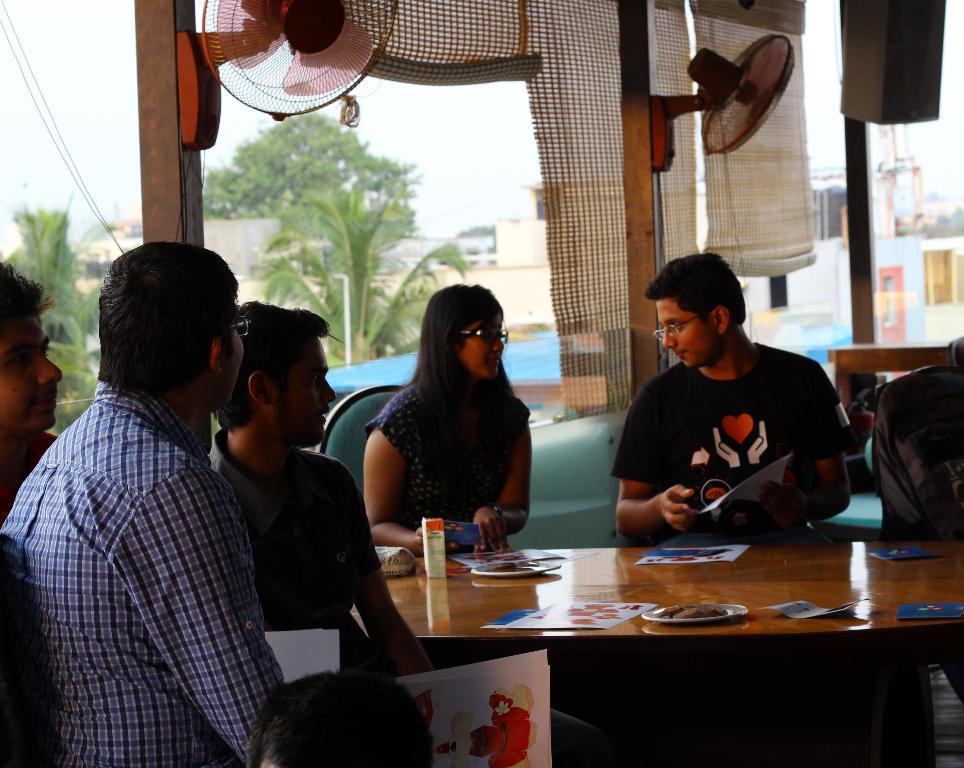Please provide a concise description of this image. In this image i can see a group of people are sitting on a chair in front of a table. On the table we have some other objects on it. 